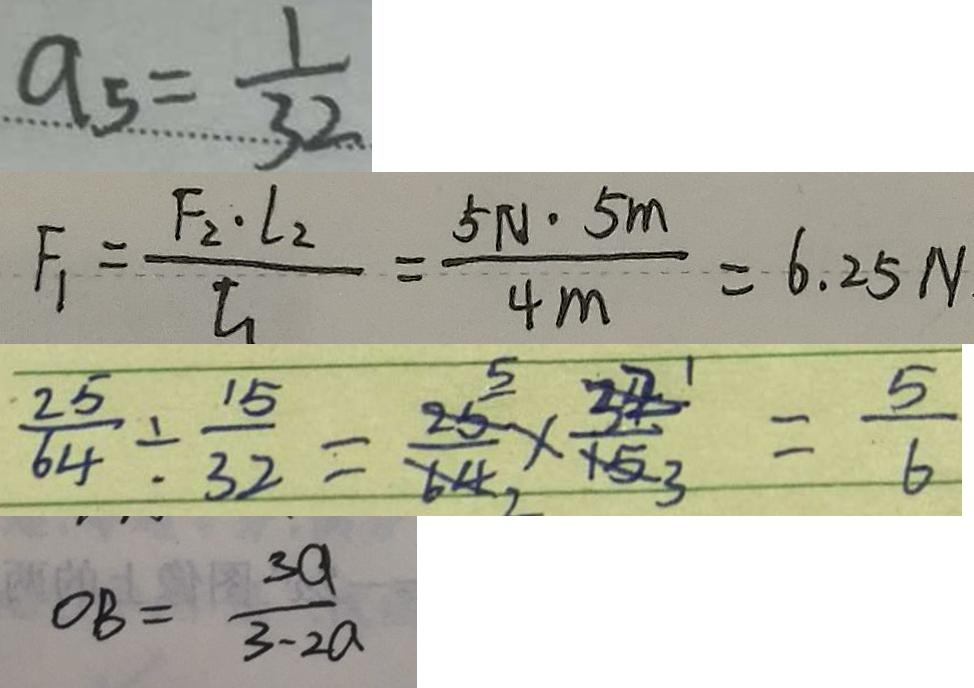<formula> <loc_0><loc_0><loc_500><loc_500>a _ { 5 } = \frac { 1 } { 3 2 } 
 F _ { 1 } = \frac { F _ { 2 } \cdot l _ { 2 } } { l _ { 1 } } = \frac { 5 N \cdot 5 m } { 4 m } = 6 . 2 5 N 
 \frac { 2 5 } { 6 4 } \div \frac { 1 5 } { 3 2 } = \frac { 2 5 } { 6 4 } \times \frac { 3 2 } { 1 5 } = \frac { 5 } { 6 } 
 O B = \frac { 3 a } { 3 - 2 a }</formula> 